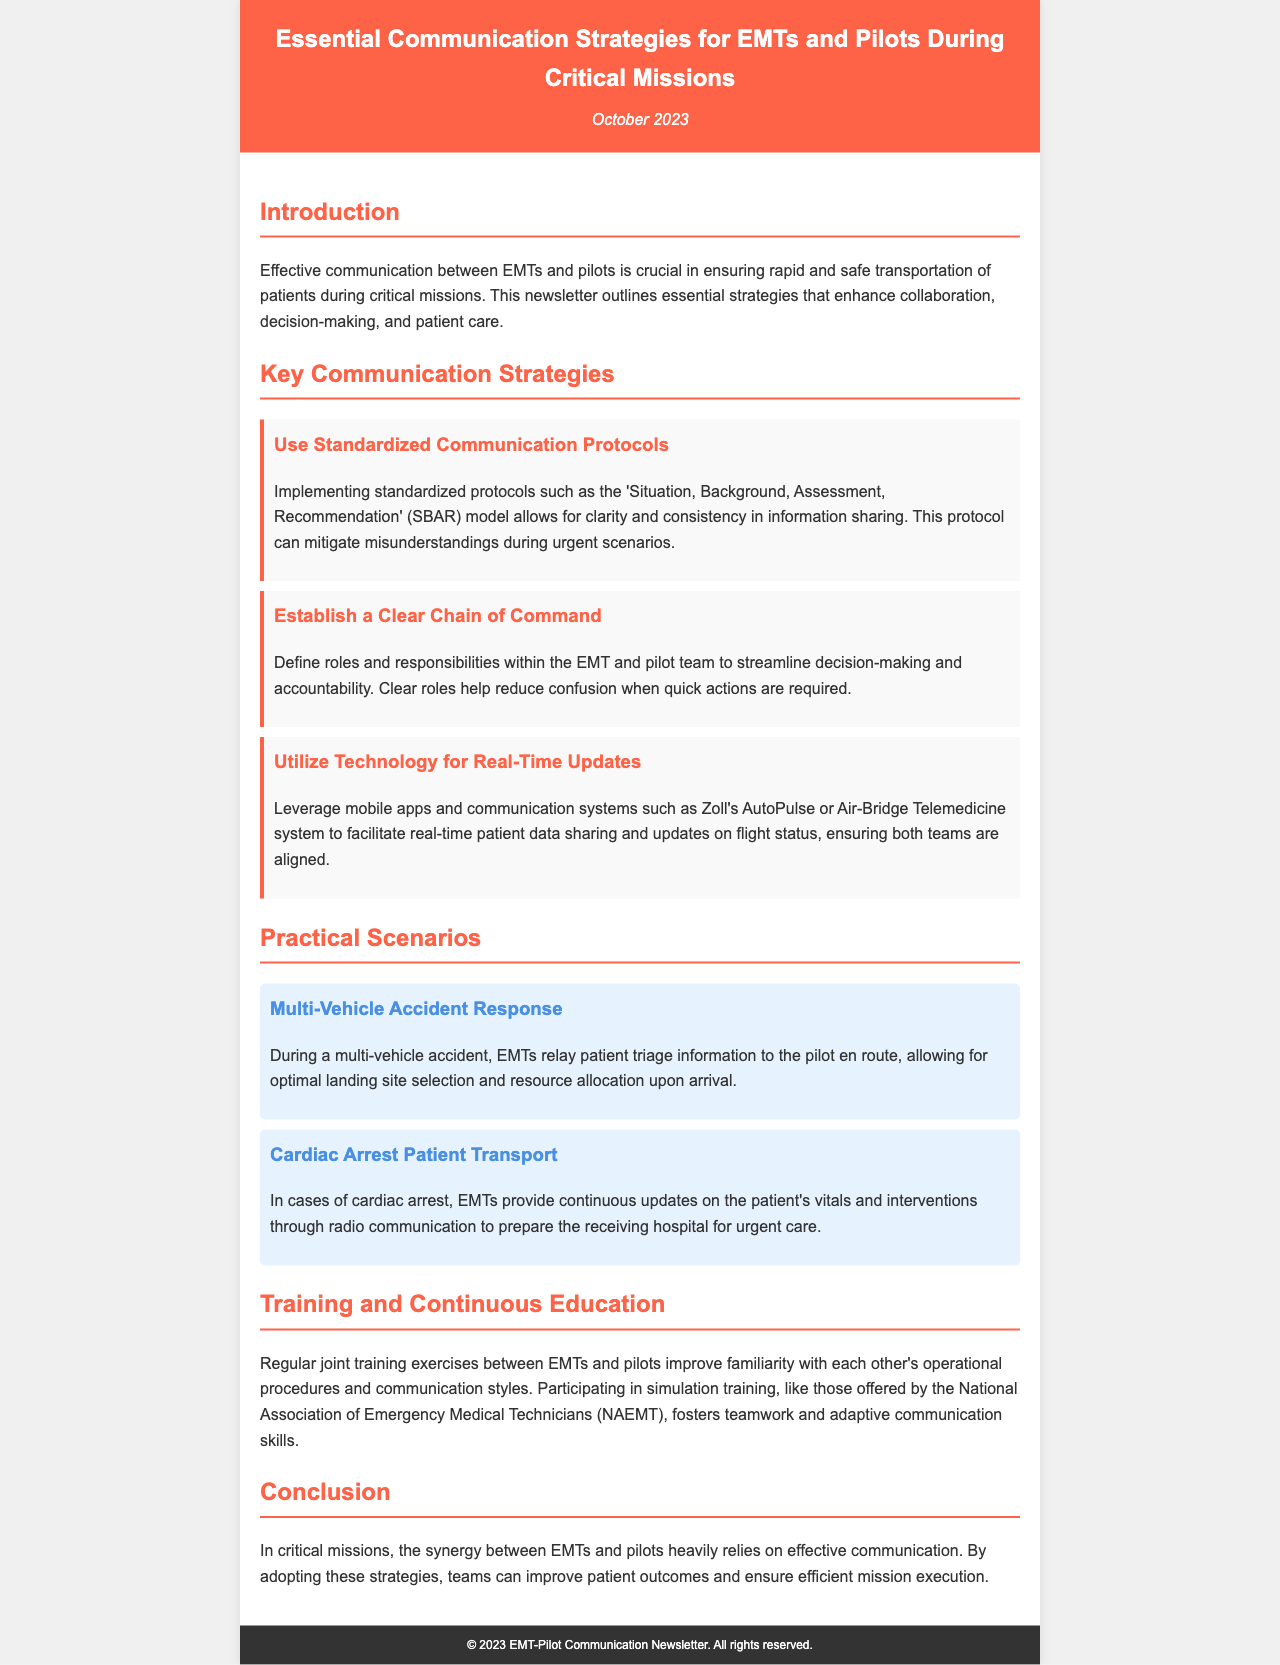What is the date of the newsletter? The date is specified in the header of the newsletter, indicating when it was released.
Answer: October 2023 What communication model is mentioned? The newsletter outlines communication protocols and specifically mentions the SBAR model as a standardized protocol for sharing information.
Answer: SBAR What is one key strategy for improving communication mentioned in the document? The document lists several strategies, one being the use of standardized communication protocols.
Answer: Standardized communication protocols What scenario involves a cardiac arrest patient? The newsletter provides scenarios that illustrate various situations, one of which specifically addresses the transport of a cardiac arrest patient.
Answer: Cardiac Arrest Patient Transport Which organization offers simulation training mentioned in the newsletter? The document references a specific organization that provides training exercises aimed at enhancing communication skills among EMTs and pilots.
Answer: National Association of Emergency Medical Technicians What is the main benefit of joint training exercises? The newsletter discusses the advantages of joint training exercises, highlighting improved operational familiarity as a result.
Answer: Improved familiarity What color is used for the header background? The header of the newsletter features a distinct color, which is indicated in the styling section of the document.
Answer: FF6347 How do EMTs communicate patient updates during a multi-vehicle accident? The document describes how EMTs can relay patient triage information effectively in urgent situations.
Answer: Through radio communication 